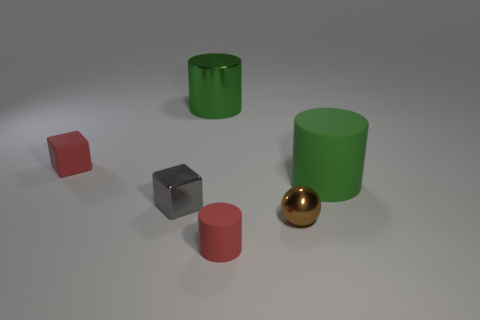There is a block that is the same color as the small rubber cylinder; what material is it? The block sharing the same color as the small rubber cylinder is also made of rubber, which is evident from its matte surface and similarity in appearance to the known rubber object. 